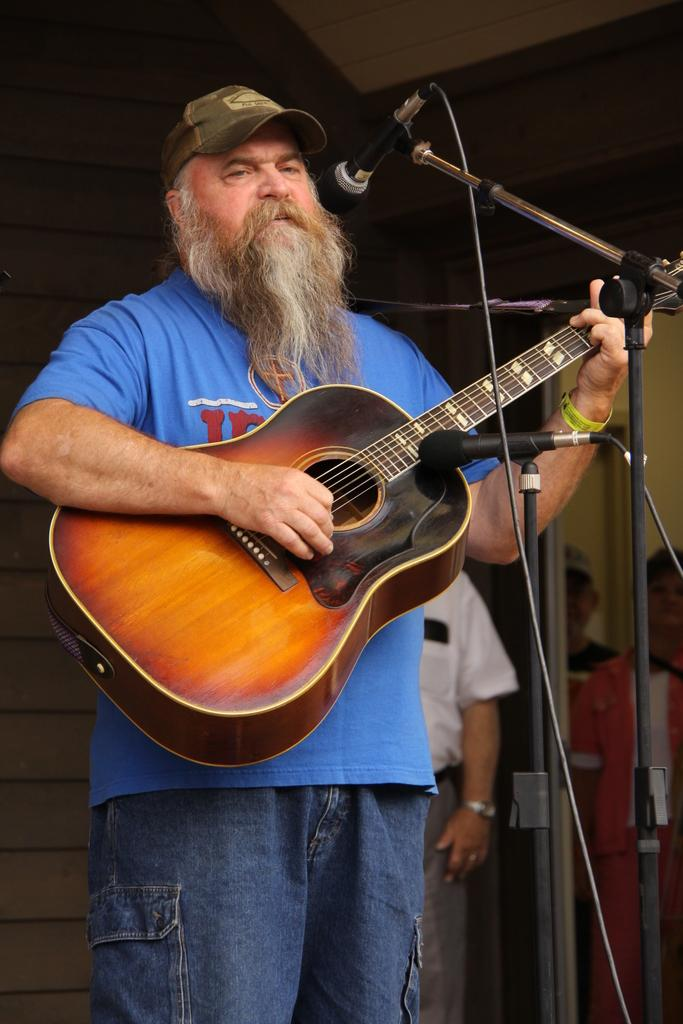What is the main subject of the image? The main subject of the image is a man. What is the man doing in the image? The man is standing in front of microphones and holding a guitar. What is the man wearing on his head? The man is wearing a cap. Can you describe the background of the image? There are people visible in the background of the image. What degree does the man offer to the people in the background? The image does not show the man offering any degree to the people in the background. 